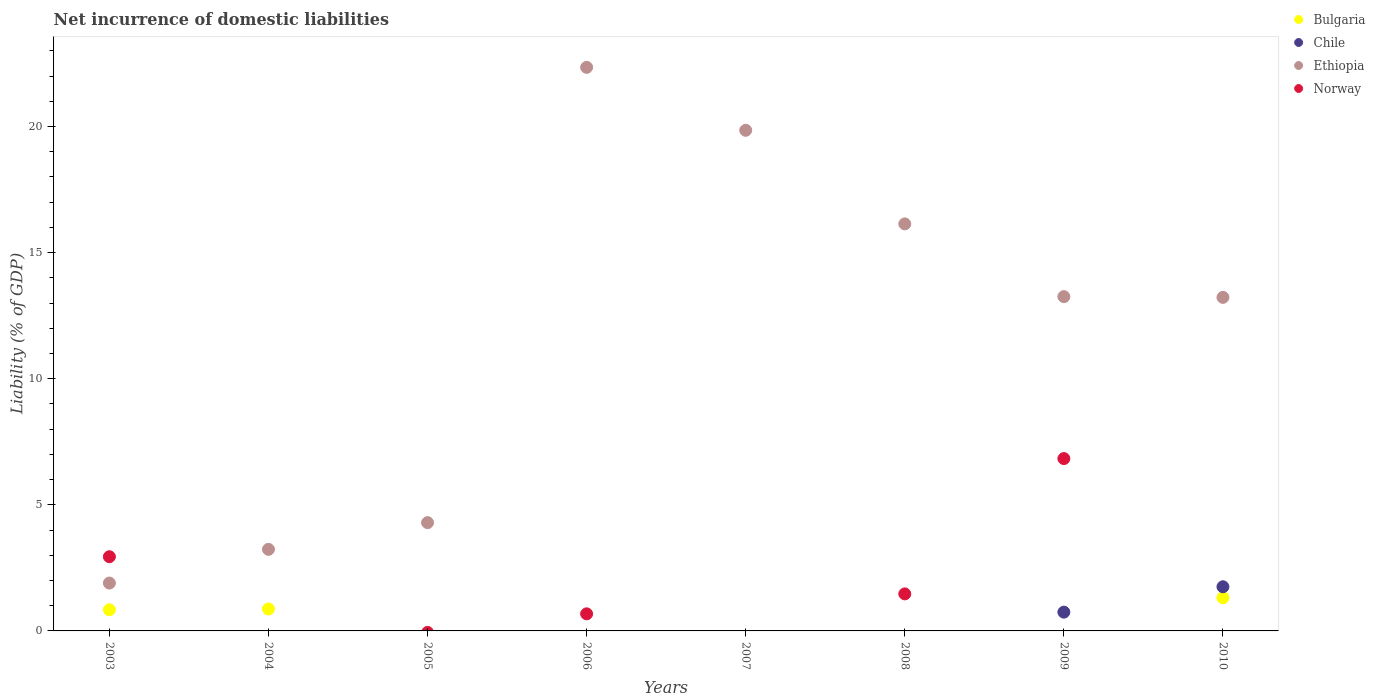How many different coloured dotlines are there?
Keep it short and to the point. 4. Is the number of dotlines equal to the number of legend labels?
Your answer should be very brief. No. Across all years, what is the maximum net incurrence of domestic liabilities in Bulgaria?
Offer a very short reply. 1.31. Across all years, what is the minimum net incurrence of domestic liabilities in Ethiopia?
Offer a terse response. 1.9. In which year was the net incurrence of domestic liabilities in Ethiopia maximum?
Offer a terse response. 2006. What is the total net incurrence of domestic liabilities in Chile in the graph?
Provide a short and direct response. 2.5. What is the difference between the net incurrence of domestic liabilities in Ethiopia in 2006 and that in 2008?
Offer a very short reply. 6.21. What is the difference between the net incurrence of domestic liabilities in Norway in 2006 and the net incurrence of domestic liabilities in Chile in 2004?
Make the answer very short. 0.68. What is the average net incurrence of domestic liabilities in Chile per year?
Provide a succinct answer. 0.31. In the year 2004, what is the difference between the net incurrence of domestic liabilities in Bulgaria and net incurrence of domestic liabilities in Ethiopia?
Ensure brevity in your answer.  -2.36. In how many years, is the net incurrence of domestic liabilities in Bulgaria greater than 12 %?
Your answer should be very brief. 0. What is the ratio of the net incurrence of domestic liabilities in Ethiopia in 2004 to that in 2005?
Your answer should be very brief. 0.75. Is the difference between the net incurrence of domestic liabilities in Bulgaria in 2004 and 2010 greater than the difference between the net incurrence of domestic liabilities in Ethiopia in 2004 and 2010?
Offer a very short reply. Yes. What is the difference between the highest and the second highest net incurrence of domestic liabilities in Bulgaria?
Offer a terse response. 0.44. What is the difference between the highest and the lowest net incurrence of domestic liabilities in Norway?
Ensure brevity in your answer.  6.83. Is it the case that in every year, the sum of the net incurrence of domestic liabilities in Norway and net incurrence of domestic liabilities in Bulgaria  is greater than the sum of net incurrence of domestic liabilities in Ethiopia and net incurrence of domestic liabilities in Chile?
Your response must be concise. No. Is it the case that in every year, the sum of the net incurrence of domestic liabilities in Ethiopia and net incurrence of domestic liabilities in Norway  is greater than the net incurrence of domestic liabilities in Chile?
Provide a succinct answer. Yes. Does the net incurrence of domestic liabilities in Chile monotonically increase over the years?
Give a very brief answer. No. Is the net incurrence of domestic liabilities in Chile strictly greater than the net incurrence of domestic liabilities in Norway over the years?
Give a very brief answer. No. How many dotlines are there?
Provide a succinct answer. 4. What is the difference between two consecutive major ticks on the Y-axis?
Offer a terse response. 5. Are the values on the major ticks of Y-axis written in scientific E-notation?
Provide a short and direct response. No. Where does the legend appear in the graph?
Provide a short and direct response. Top right. What is the title of the graph?
Give a very brief answer. Net incurrence of domestic liabilities. Does "Nigeria" appear as one of the legend labels in the graph?
Give a very brief answer. No. What is the label or title of the X-axis?
Provide a succinct answer. Years. What is the label or title of the Y-axis?
Your response must be concise. Liability (% of GDP). What is the Liability (% of GDP) of Bulgaria in 2003?
Make the answer very short. 0.84. What is the Liability (% of GDP) in Ethiopia in 2003?
Offer a terse response. 1.9. What is the Liability (% of GDP) in Norway in 2003?
Provide a succinct answer. 2.94. What is the Liability (% of GDP) in Bulgaria in 2004?
Offer a terse response. 0.87. What is the Liability (% of GDP) in Chile in 2004?
Make the answer very short. 0. What is the Liability (% of GDP) in Ethiopia in 2004?
Your answer should be compact. 3.23. What is the Liability (% of GDP) in Norway in 2004?
Offer a terse response. 0. What is the Liability (% of GDP) of Ethiopia in 2005?
Your answer should be compact. 4.29. What is the Liability (% of GDP) of Bulgaria in 2006?
Keep it short and to the point. 0. What is the Liability (% of GDP) in Chile in 2006?
Ensure brevity in your answer.  0. What is the Liability (% of GDP) in Ethiopia in 2006?
Offer a terse response. 22.34. What is the Liability (% of GDP) of Norway in 2006?
Your answer should be compact. 0.68. What is the Liability (% of GDP) in Ethiopia in 2007?
Your answer should be very brief. 19.85. What is the Liability (% of GDP) in Chile in 2008?
Your answer should be compact. 0. What is the Liability (% of GDP) in Ethiopia in 2008?
Make the answer very short. 16.14. What is the Liability (% of GDP) in Norway in 2008?
Ensure brevity in your answer.  1.47. What is the Liability (% of GDP) in Chile in 2009?
Your answer should be very brief. 0.74. What is the Liability (% of GDP) of Ethiopia in 2009?
Your answer should be compact. 13.25. What is the Liability (% of GDP) of Norway in 2009?
Your response must be concise. 6.83. What is the Liability (% of GDP) of Bulgaria in 2010?
Make the answer very short. 1.31. What is the Liability (% of GDP) in Chile in 2010?
Provide a short and direct response. 1.75. What is the Liability (% of GDP) of Ethiopia in 2010?
Your answer should be compact. 13.22. Across all years, what is the maximum Liability (% of GDP) in Bulgaria?
Your response must be concise. 1.31. Across all years, what is the maximum Liability (% of GDP) in Chile?
Your answer should be very brief. 1.75. Across all years, what is the maximum Liability (% of GDP) in Ethiopia?
Offer a very short reply. 22.34. Across all years, what is the maximum Liability (% of GDP) of Norway?
Provide a short and direct response. 6.83. Across all years, what is the minimum Liability (% of GDP) in Chile?
Give a very brief answer. 0. Across all years, what is the minimum Liability (% of GDP) of Ethiopia?
Give a very brief answer. 1.9. What is the total Liability (% of GDP) of Bulgaria in the graph?
Make the answer very short. 3.02. What is the total Liability (% of GDP) of Chile in the graph?
Ensure brevity in your answer.  2.5. What is the total Liability (% of GDP) of Ethiopia in the graph?
Make the answer very short. 94.23. What is the total Liability (% of GDP) in Norway in the graph?
Your response must be concise. 11.92. What is the difference between the Liability (% of GDP) in Bulgaria in 2003 and that in 2004?
Your answer should be compact. -0.03. What is the difference between the Liability (% of GDP) in Ethiopia in 2003 and that in 2004?
Provide a succinct answer. -1.34. What is the difference between the Liability (% of GDP) of Ethiopia in 2003 and that in 2005?
Your answer should be compact. -2.4. What is the difference between the Liability (% of GDP) in Ethiopia in 2003 and that in 2006?
Provide a short and direct response. -20.45. What is the difference between the Liability (% of GDP) of Norway in 2003 and that in 2006?
Give a very brief answer. 2.26. What is the difference between the Liability (% of GDP) of Ethiopia in 2003 and that in 2007?
Keep it short and to the point. -17.95. What is the difference between the Liability (% of GDP) in Ethiopia in 2003 and that in 2008?
Give a very brief answer. -14.24. What is the difference between the Liability (% of GDP) in Norway in 2003 and that in 2008?
Make the answer very short. 1.47. What is the difference between the Liability (% of GDP) of Ethiopia in 2003 and that in 2009?
Provide a short and direct response. -11.36. What is the difference between the Liability (% of GDP) of Norway in 2003 and that in 2009?
Your answer should be very brief. -3.89. What is the difference between the Liability (% of GDP) in Bulgaria in 2003 and that in 2010?
Offer a very short reply. -0.48. What is the difference between the Liability (% of GDP) of Ethiopia in 2003 and that in 2010?
Offer a very short reply. -11.33. What is the difference between the Liability (% of GDP) of Ethiopia in 2004 and that in 2005?
Provide a succinct answer. -1.06. What is the difference between the Liability (% of GDP) in Ethiopia in 2004 and that in 2006?
Your answer should be compact. -19.11. What is the difference between the Liability (% of GDP) in Ethiopia in 2004 and that in 2007?
Provide a succinct answer. -16.61. What is the difference between the Liability (% of GDP) in Ethiopia in 2004 and that in 2008?
Provide a succinct answer. -12.9. What is the difference between the Liability (% of GDP) in Ethiopia in 2004 and that in 2009?
Offer a terse response. -10.02. What is the difference between the Liability (% of GDP) in Bulgaria in 2004 and that in 2010?
Ensure brevity in your answer.  -0.44. What is the difference between the Liability (% of GDP) in Ethiopia in 2004 and that in 2010?
Ensure brevity in your answer.  -9.99. What is the difference between the Liability (% of GDP) of Ethiopia in 2005 and that in 2006?
Your response must be concise. -18.05. What is the difference between the Liability (% of GDP) of Ethiopia in 2005 and that in 2007?
Keep it short and to the point. -15.55. What is the difference between the Liability (% of GDP) in Ethiopia in 2005 and that in 2008?
Your answer should be compact. -11.84. What is the difference between the Liability (% of GDP) of Ethiopia in 2005 and that in 2009?
Offer a very short reply. -8.96. What is the difference between the Liability (% of GDP) in Ethiopia in 2005 and that in 2010?
Your answer should be compact. -8.93. What is the difference between the Liability (% of GDP) of Ethiopia in 2006 and that in 2007?
Provide a short and direct response. 2.5. What is the difference between the Liability (% of GDP) in Ethiopia in 2006 and that in 2008?
Make the answer very short. 6.21. What is the difference between the Liability (% of GDP) in Norway in 2006 and that in 2008?
Keep it short and to the point. -0.79. What is the difference between the Liability (% of GDP) in Ethiopia in 2006 and that in 2009?
Your answer should be compact. 9.09. What is the difference between the Liability (% of GDP) of Norway in 2006 and that in 2009?
Offer a very short reply. -6.16. What is the difference between the Liability (% of GDP) in Ethiopia in 2006 and that in 2010?
Provide a short and direct response. 9.12. What is the difference between the Liability (% of GDP) of Ethiopia in 2007 and that in 2008?
Your response must be concise. 3.71. What is the difference between the Liability (% of GDP) of Ethiopia in 2007 and that in 2009?
Offer a very short reply. 6.59. What is the difference between the Liability (% of GDP) of Ethiopia in 2007 and that in 2010?
Make the answer very short. 6.62. What is the difference between the Liability (% of GDP) in Ethiopia in 2008 and that in 2009?
Provide a short and direct response. 2.88. What is the difference between the Liability (% of GDP) of Norway in 2008 and that in 2009?
Your response must be concise. -5.36. What is the difference between the Liability (% of GDP) in Ethiopia in 2008 and that in 2010?
Keep it short and to the point. 2.91. What is the difference between the Liability (% of GDP) in Chile in 2009 and that in 2010?
Keep it short and to the point. -1.01. What is the difference between the Liability (% of GDP) of Ethiopia in 2009 and that in 2010?
Offer a terse response. 0.03. What is the difference between the Liability (% of GDP) of Bulgaria in 2003 and the Liability (% of GDP) of Ethiopia in 2004?
Your answer should be very brief. -2.4. What is the difference between the Liability (% of GDP) of Bulgaria in 2003 and the Liability (% of GDP) of Ethiopia in 2005?
Provide a succinct answer. -3.45. What is the difference between the Liability (% of GDP) of Bulgaria in 2003 and the Liability (% of GDP) of Ethiopia in 2006?
Make the answer very short. -21.5. What is the difference between the Liability (% of GDP) of Bulgaria in 2003 and the Liability (% of GDP) of Norway in 2006?
Your response must be concise. 0.16. What is the difference between the Liability (% of GDP) in Ethiopia in 2003 and the Liability (% of GDP) in Norway in 2006?
Offer a very short reply. 1.22. What is the difference between the Liability (% of GDP) in Bulgaria in 2003 and the Liability (% of GDP) in Ethiopia in 2007?
Make the answer very short. -19.01. What is the difference between the Liability (% of GDP) in Bulgaria in 2003 and the Liability (% of GDP) in Ethiopia in 2008?
Offer a very short reply. -15.3. What is the difference between the Liability (% of GDP) of Bulgaria in 2003 and the Liability (% of GDP) of Norway in 2008?
Keep it short and to the point. -0.63. What is the difference between the Liability (% of GDP) of Ethiopia in 2003 and the Liability (% of GDP) of Norway in 2008?
Your answer should be compact. 0.43. What is the difference between the Liability (% of GDP) of Bulgaria in 2003 and the Liability (% of GDP) of Chile in 2009?
Give a very brief answer. 0.09. What is the difference between the Liability (% of GDP) in Bulgaria in 2003 and the Liability (% of GDP) in Ethiopia in 2009?
Keep it short and to the point. -12.41. What is the difference between the Liability (% of GDP) of Bulgaria in 2003 and the Liability (% of GDP) of Norway in 2009?
Provide a succinct answer. -5.99. What is the difference between the Liability (% of GDP) in Ethiopia in 2003 and the Liability (% of GDP) in Norway in 2009?
Make the answer very short. -4.94. What is the difference between the Liability (% of GDP) of Bulgaria in 2003 and the Liability (% of GDP) of Chile in 2010?
Your answer should be very brief. -0.91. What is the difference between the Liability (% of GDP) in Bulgaria in 2003 and the Liability (% of GDP) in Ethiopia in 2010?
Offer a very short reply. -12.39. What is the difference between the Liability (% of GDP) in Bulgaria in 2004 and the Liability (% of GDP) in Ethiopia in 2005?
Offer a terse response. -3.42. What is the difference between the Liability (% of GDP) of Bulgaria in 2004 and the Liability (% of GDP) of Ethiopia in 2006?
Provide a succinct answer. -21.47. What is the difference between the Liability (% of GDP) of Bulgaria in 2004 and the Liability (% of GDP) of Norway in 2006?
Provide a succinct answer. 0.19. What is the difference between the Liability (% of GDP) of Ethiopia in 2004 and the Liability (% of GDP) of Norway in 2006?
Your response must be concise. 2.56. What is the difference between the Liability (% of GDP) in Bulgaria in 2004 and the Liability (% of GDP) in Ethiopia in 2007?
Offer a very short reply. -18.98. What is the difference between the Liability (% of GDP) in Bulgaria in 2004 and the Liability (% of GDP) in Ethiopia in 2008?
Provide a succinct answer. -15.27. What is the difference between the Liability (% of GDP) of Bulgaria in 2004 and the Liability (% of GDP) of Norway in 2008?
Give a very brief answer. -0.6. What is the difference between the Liability (% of GDP) in Ethiopia in 2004 and the Liability (% of GDP) in Norway in 2008?
Make the answer very short. 1.77. What is the difference between the Liability (% of GDP) in Bulgaria in 2004 and the Liability (% of GDP) in Chile in 2009?
Offer a very short reply. 0.13. What is the difference between the Liability (% of GDP) of Bulgaria in 2004 and the Liability (% of GDP) of Ethiopia in 2009?
Ensure brevity in your answer.  -12.38. What is the difference between the Liability (% of GDP) in Bulgaria in 2004 and the Liability (% of GDP) in Norway in 2009?
Keep it short and to the point. -5.96. What is the difference between the Liability (% of GDP) in Ethiopia in 2004 and the Liability (% of GDP) in Norway in 2009?
Provide a short and direct response. -3.6. What is the difference between the Liability (% of GDP) in Bulgaria in 2004 and the Liability (% of GDP) in Chile in 2010?
Offer a terse response. -0.88. What is the difference between the Liability (% of GDP) of Bulgaria in 2004 and the Liability (% of GDP) of Ethiopia in 2010?
Your response must be concise. -12.35. What is the difference between the Liability (% of GDP) of Ethiopia in 2005 and the Liability (% of GDP) of Norway in 2006?
Your response must be concise. 3.62. What is the difference between the Liability (% of GDP) of Ethiopia in 2005 and the Liability (% of GDP) of Norway in 2008?
Your response must be concise. 2.82. What is the difference between the Liability (% of GDP) in Ethiopia in 2005 and the Liability (% of GDP) in Norway in 2009?
Ensure brevity in your answer.  -2.54. What is the difference between the Liability (% of GDP) in Ethiopia in 2006 and the Liability (% of GDP) in Norway in 2008?
Your answer should be compact. 20.87. What is the difference between the Liability (% of GDP) in Ethiopia in 2006 and the Liability (% of GDP) in Norway in 2009?
Your response must be concise. 15.51. What is the difference between the Liability (% of GDP) in Ethiopia in 2007 and the Liability (% of GDP) in Norway in 2008?
Provide a short and direct response. 18.38. What is the difference between the Liability (% of GDP) of Ethiopia in 2007 and the Liability (% of GDP) of Norway in 2009?
Offer a terse response. 13.02. What is the difference between the Liability (% of GDP) in Ethiopia in 2008 and the Liability (% of GDP) in Norway in 2009?
Make the answer very short. 9.3. What is the difference between the Liability (% of GDP) of Chile in 2009 and the Liability (% of GDP) of Ethiopia in 2010?
Your answer should be compact. -12.48. What is the average Liability (% of GDP) of Bulgaria per year?
Offer a terse response. 0.38. What is the average Liability (% of GDP) of Chile per year?
Provide a short and direct response. 0.31. What is the average Liability (% of GDP) in Ethiopia per year?
Provide a short and direct response. 11.78. What is the average Liability (% of GDP) in Norway per year?
Your answer should be very brief. 1.49. In the year 2003, what is the difference between the Liability (% of GDP) of Bulgaria and Liability (% of GDP) of Ethiopia?
Keep it short and to the point. -1.06. In the year 2003, what is the difference between the Liability (% of GDP) of Bulgaria and Liability (% of GDP) of Norway?
Make the answer very short. -2.1. In the year 2003, what is the difference between the Liability (% of GDP) in Ethiopia and Liability (% of GDP) in Norway?
Provide a succinct answer. -1.04. In the year 2004, what is the difference between the Liability (% of GDP) of Bulgaria and Liability (% of GDP) of Ethiopia?
Give a very brief answer. -2.36. In the year 2006, what is the difference between the Liability (% of GDP) of Ethiopia and Liability (% of GDP) of Norway?
Provide a short and direct response. 21.67. In the year 2008, what is the difference between the Liability (% of GDP) in Ethiopia and Liability (% of GDP) in Norway?
Make the answer very short. 14.67. In the year 2009, what is the difference between the Liability (% of GDP) in Chile and Liability (% of GDP) in Ethiopia?
Ensure brevity in your answer.  -12.51. In the year 2009, what is the difference between the Liability (% of GDP) of Chile and Liability (% of GDP) of Norway?
Provide a short and direct response. -6.09. In the year 2009, what is the difference between the Liability (% of GDP) of Ethiopia and Liability (% of GDP) of Norway?
Your answer should be very brief. 6.42. In the year 2010, what is the difference between the Liability (% of GDP) of Bulgaria and Liability (% of GDP) of Chile?
Your answer should be very brief. -0.44. In the year 2010, what is the difference between the Liability (% of GDP) of Bulgaria and Liability (% of GDP) of Ethiopia?
Your answer should be compact. -11.91. In the year 2010, what is the difference between the Liability (% of GDP) in Chile and Liability (% of GDP) in Ethiopia?
Keep it short and to the point. -11.47. What is the ratio of the Liability (% of GDP) in Bulgaria in 2003 to that in 2004?
Your answer should be very brief. 0.96. What is the ratio of the Liability (% of GDP) of Ethiopia in 2003 to that in 2004?
Offer a very short reply. 0.59. What is the ratio of the Liability (% of GDP) in Ethiopia in 2003 to that in 2005?
Ensure brevity in your answer.  0.44. What is the ratio of the Liability (% of GDP) of Ethiopia in 2003 to that in 2006?
Make the answer very short. 0.08. What is the ratio of the Liability (% of GDP) in Norway in 2003 to that in 2006?
Your answer should be compact. 4.34. What is the ratio of the Liability (% of GDP) in Ethiopia in 2003 to that in 2007?
Offer a very short reply. 0.1. What is the ratio of the Liability (% of GDP) in Ethiopia in 2003 to that in 2008?
Make the answer very short. 0.12. What is the ratio of the Liability (% of GDP) in Norway in 2003 to that in 2008?
Offer a very short reply. 2. What is the ratio of the Liability (% of GDP) in Ethiopia in 2003 to that in 2009?
Give a very brief answer. 0.14. What is the ratio of the Liability (% of GDP) in Norway in 2003 to that in 2009?
Your response must be concise. 0.43. What is the ratio of the Liability (% of GDP) in Bulgaria in 2003 to that in 2010?
Offer a very short reply. 0.64. What is the ratio of the Liability (% of GDP) of Ethiopia in 2003 to that in 2010?
Offer a terse response. 0.14. What is the ratio of the Liability (% of GDP) of Ethiopia in 2004 to that in 2005?
Give a very brief answer. 0.75. What is the ratio of the Liability (% of GDP) of Ethiopia in 2004 to that in 2006?
Your answer should be very brief. 0.14. What is the ratio of the Liability (% of GDP) in Ethiopia in 2004 to that in 2007?
Ensure brevity in your answer.  0.16. What is the ratio of the Liability (% of GDP) in Ethiopia in 2004 to that in 2008?
Provide a succinct answer. 0.2. What is the ratio of the Liability (% of GDP) in Ethiopia in 2004 to that in 2009?
Ensure brevity in your answer.  0.24. What is the ratio of the Liability (% of GDP) in Bulgaria in 2004 to that in 2010?
Your answer should be compact. 0.66. What is the ratio of the Liability (% of GDP) in Ethiopia in 2004 to that in 2010?
Ensure brevity in your answer.  0.24. What is the ratio of the Liability (% of GDP) of Ethiopia in 2005 to that in 2006?
Give a very brief answer. 0.19. What is the ratio of the Liability (% of GDP) in Ethiopia in 2005 to that in 2007?
Keep it short and to the point. 0.22. What is the ratio of the Liability (% of GDP) of Ethiopia in 2005 to that in 2008?
Provide a short and direct response. 0.27. What is the ratio of the Liability (% of GDP) of Ethiopia in 2005 to that in 2009?
Give a very brief answer. 0.32. What is the ratio of the Liability (% of GDP) of Ethiopia in 2005 to that in 2010?
Provide a short and direct response. 0.32. What is the ratio of the Liability (% of GDP) of Ethiopia in 2006 to that in 2007?
Your response must be concise. 1.13. What is the ratio of the Liability (% of GDP) of Ethiopia in 2006 to that in 2008?
Provide a succinct answer. 1.38. What is the ratio of the Liability (% of GDP) of Norway in 2006 to that in 2008?
Offer a terse response. 0.46. What is the ratio of the Liability (% of GDP) of Ethiopia in 2006 to that in 2009?
Give a very brief answer. 1.69. What is the ratio of the Liability (% of GDP) of Norway in 2006 to that in 2009?
Give a very brief answer. 0.1. What is the ratio of the Liability (% of GDP) in Ethiopia in 2006 to that in 2010?
Offer a terse response. 1.69. What is the ratio of the Liability (% of GDP) in Ethiopia in 2007 to that in 2008?
Provide a short and direct response. 1.23. What is the ratio of the Liability (% of GDP) in Ethiopia in 2007 to that in 2009?
Offer a very short reply. 1.5. What is the ratio of the Liability (% of GDP) in Ethiopia in 2007 to that in 2010?
Provide a short and direct response. 1.5. What is the ratio of the Liability (% of GDP) of Ethiopia in 2008 to that in 2009?
Make the answer very short. 1.22. What is the ratio of the Liability (% of GDP) in Norway in 2008 to that in 2009?
Your response must be concise. 0.21. What is the ratio of the Liability (% of GDP) in Ethiopia in 2008 to that in 2010?
Give a very brief answer. 1.22. What is the ratio of the Liability (% of GDP) in Chile in 2009 to that in 2010?
Keep it short and to the point. 0.43. What is the ratio of the Liability (% of GDP) in Ethiopia in 2009 to that in 2010?
Your response must be concise. 1. What is the difference between the highest and the second highest Liability (% of GDP) of Bulgaria?
Ensure brevity in your answer.  0.44. What is the difference between the highest and the second highest Liability (% of GDP) in Ethiopia?
Keep it short and to the point. 2.5. What is the difference between the highest and the second highest Liability (% of GDP) of Norway?
Give a very brief answer. 3.89. What is the difference between the highest and the lowest Liability (% of GDP) in Bulgaria?
Offer a very short reply. 1.31. What is the difference between the highest and the lowest Liability (% of GDP) of Chile?
Your response must be concise. 1.75. What is the difference between the highest and the lowest Liability (% of GDP) of Ethiopia?
Your answer should be very brief. 20.45. What is the difference between the highest and the lowest Liability (% of GDP) of Norway?
Offer a very short reply. 6.83. 